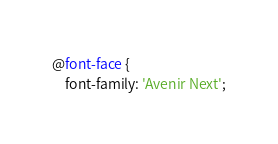Convert code to text. <code><loc_0><loc_0><loc_500><loc_500><_CSS_>@font-face {
	font-family: 'Avenir Next';</code> 